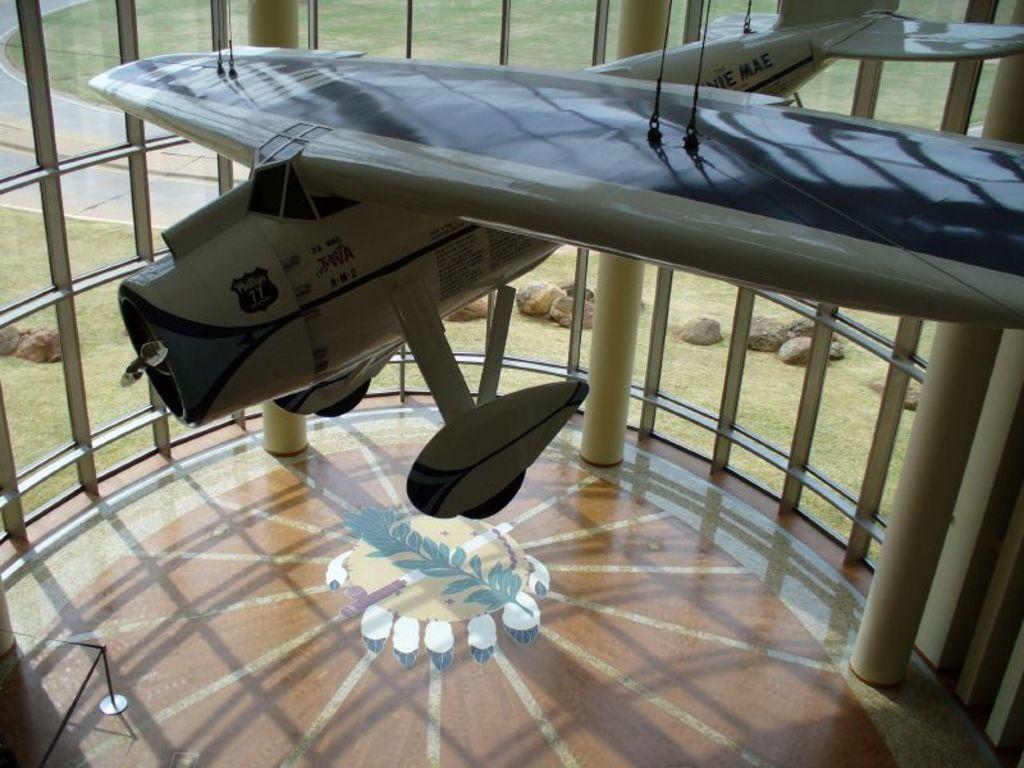Please provide a concise description of this image. At the top of this image, there is aircraft attached to the threads. Below this aircraft, there is a floor of a building having windows and pillars. In the background, there are rocks, a road and grass on the ground. 